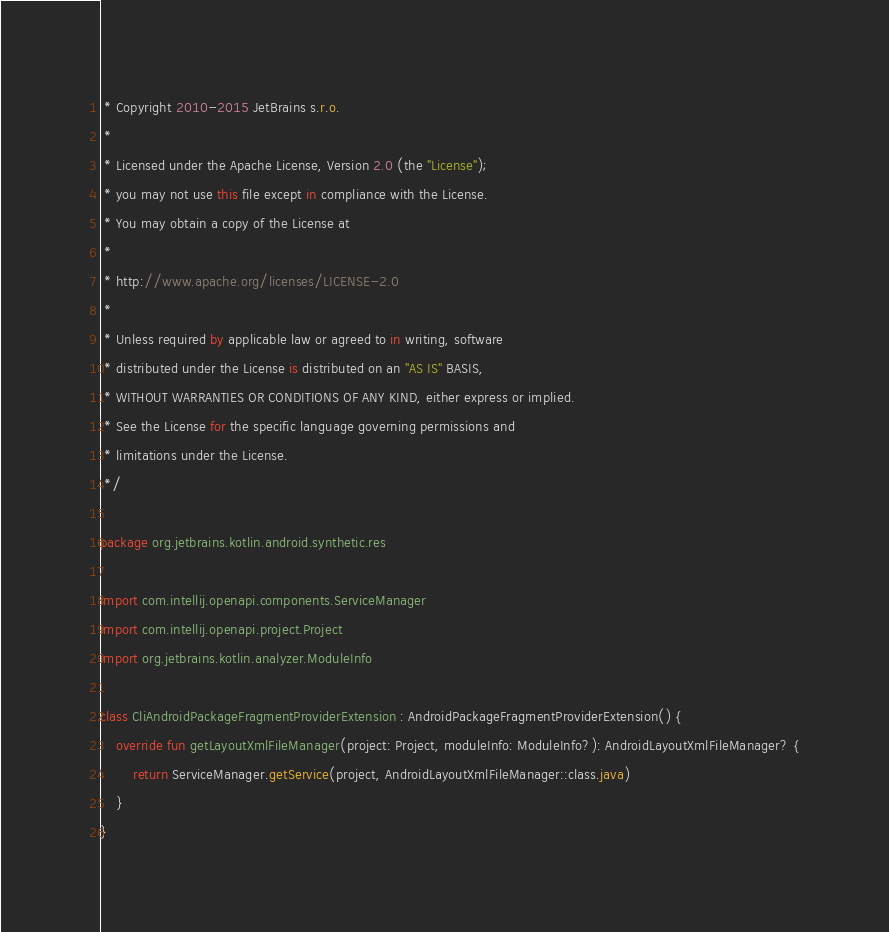<code> <loc_0><loc_0><loc_500><loc_500><_Kotlin_> * Copyright 2010-2015 JetBrains s.r.o.
 *
 * Licensed under the Apache License, Version 2.0 (the "License");
 * you may not use this file except in compliance with the License.
 * You may obtain a copy of the License at
 *
 * http://www.apache.org/licenses/LICENSE-2.0
 *
 * Unless required by applicable law or agreed to in writing, software
 * distributed under the License is distributed on an "AS IS" BASIS,
 * WITHOUT WARRANTIES OR CONDITIONS OF ANY KIND, either express or implied.
 * See the License for the specific language governing permissions and
 * limitations under the License.
 */

package org.jetbrains.kotlin.android.synthetic.res

import com.intellij.openapi.components.ServiceManager
import com.intellij.openapi.project.Project
import org.jetbrains.kotlin.analyzer.ModuleInfo

class CliAndroidPackageFragmentProviderExtension : AndroidPackageFragmentProviderExtension() {
    override fun getLayoutXmlFileManager(project: Project, moduleInfo: ModuleInfo?): AndroidLayoutXmlFileManager? {
        return ServiceManager.getService(project, AndroidLayoutXmlFileManager::class.java)
    }
}</code> 